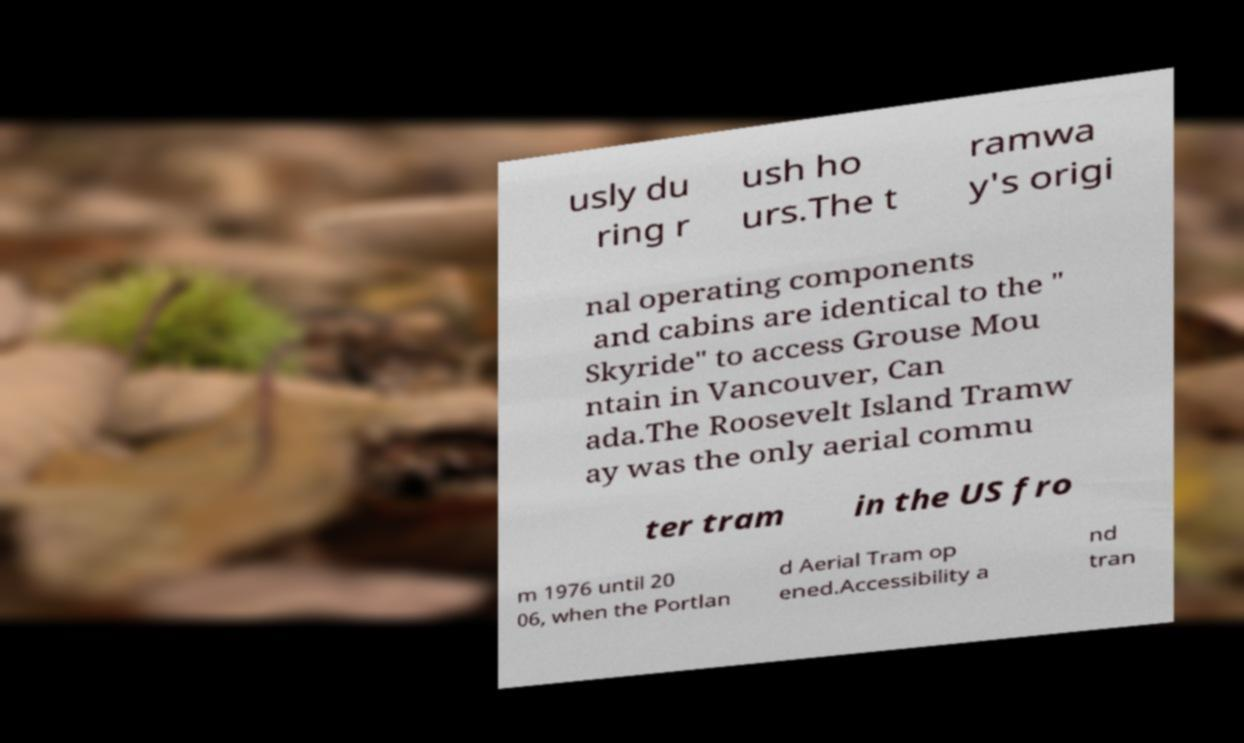I need the written content from this picture converted into text. Can you do that? usly du ring r ush ho urs.The t ramwa y's origi nal operating components and cabins are identical to the " Skyride" to access Grouse Mou ntain in Vancouver, Can ada.The Roosevelt Island Tramw ay was the only aerial commu ter tram in the US fro m 1976 until 20 06, when the Portlan d Aerial Tram op ened.Accessibility a nd tran 